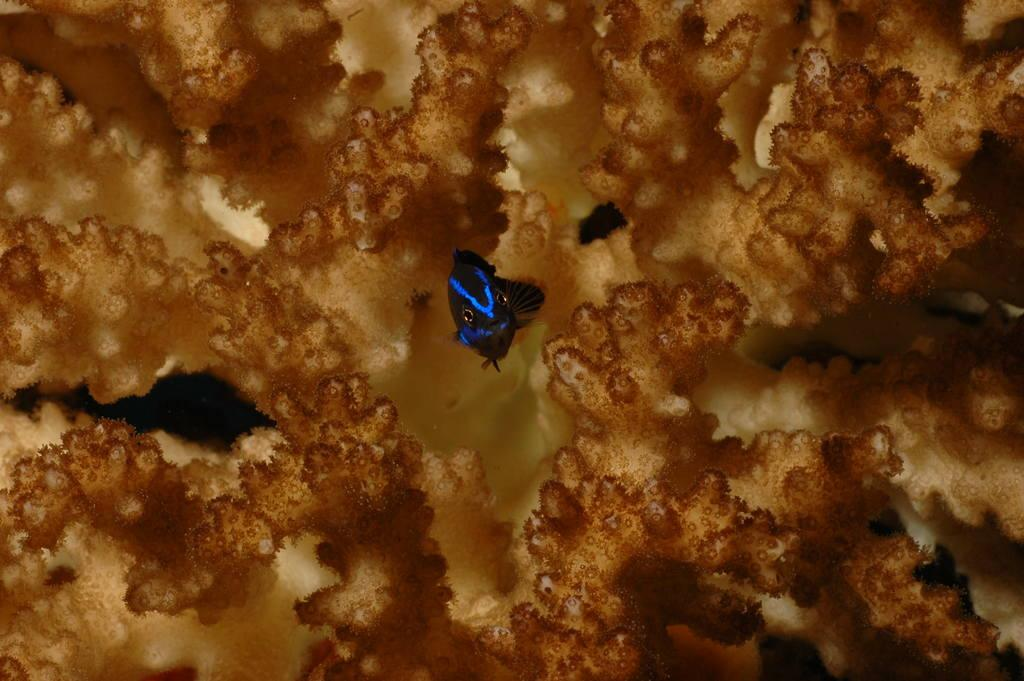What is the main subject of the image? The main subject of the image is a fish. Where is the fish located? The fish is in the water. What can be seen in the background behind the fish? There are coral-like structures visible behind the fish. What is the fish's opinion about the soda in the image? There is no soda present in the image, and fish do not have opinions. Does the fish appear to be afraid of the coral-like structures in the image? The image does not provide any information about the fish's emotions or feelings, so it cannot be determined if the fish is afraid. 